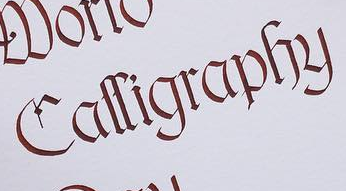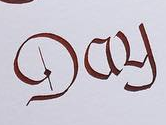Read the text content from these images in order, separated by a semicolon. Calligraphy; Day 